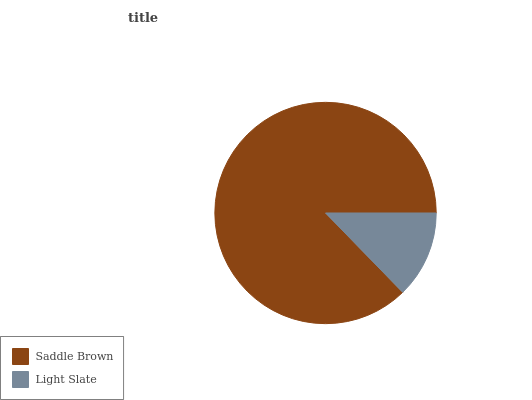Is Light Slate the minimum?
Answer yes or no. Yes. Is Saddle Brown the maximum?
Answer yes or no. Yes. Is Light Slate the maximum?
Answer yes or no. No. Is Saddle Brown greater than Light Slate?
Answer yes or no. Yes. Is Light Slate less than Saddle Brown?
Answer yes or no. Yes. Is Light Slate greater than Saddle Brown?
Answer yes or no. No. Is Saddle Brown less than Light Slate?
Answer yes or no. No. Is Saddle Brown the high median?
Answer yes or no. Yes. Is Light Slate the low median?
Answer yes or no. Yes. Is Light Slate the high median?
Answer yes or no. No. Is Saddle Brown the low median?
Answer yes or no. No. 